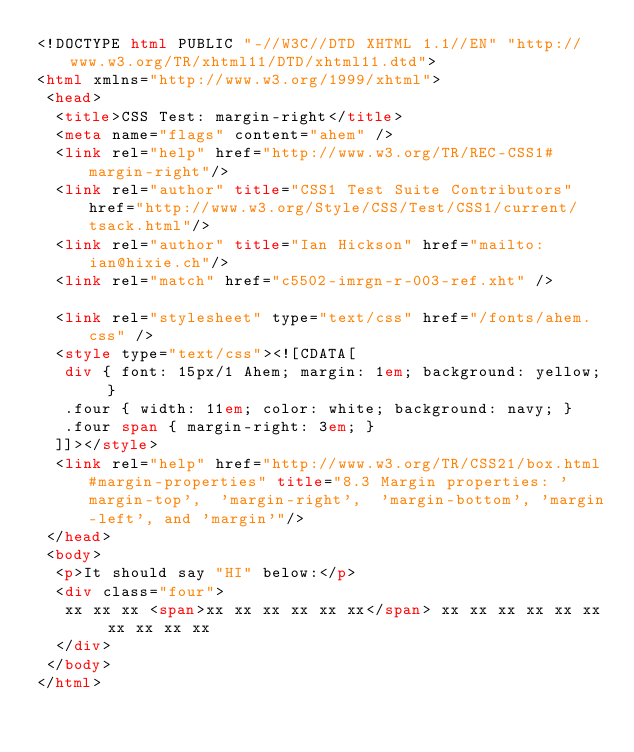Convert code to text. <code><loc_0><loc_0><loc_500><loc_500><_HTML_><!DOCTYPE html PUBLIC "-//W3C//DTD XHTML 1.1//EN" "http://www.w3.org/TR/xhtml11/DTD/xhtml11.dtd">
<html xmlns="http://www.w3.org/1999/xhtml">
 <head>
  <title>CSS Test: margin-right</title>
  <meta name="flags" content="ahem" />
  <link rel="help" href="http://www.w3.org/TR/REC-CSS1#margin-right"/>
  <link rel="author" title="CSS1 Test Suite Contributors" href="http://www.w3.org/Style/CSS/Test/CSS1/current/tsack.html"/>
  <link rel="author" title="Ian Hickson" href="mailto:ian@hixie.ch"/>
  <link rel="match" href="c5502-imrgn-r-003-ref.xht" />

  <link rel="stylesheet" type="text/css" href="/fonts/ahem.css" />
  <style type="text/css"><![CDATA[
   div { font: 15px/1 Ahem; margin: 1em; background: yellow; }
   .four { width: 11em; color: white; background: navy; }
   .four span { margin-right: 3em; }
  ]]></style>
  <link rel="help" href="http://www.w3.org/TR/CSS21/box.html#margin-properties" title="8.3 Margin properties: 'margin-top',  'margin-right',  'margin-bottom', 'margin-left', and 'margin'"/>
 </head>
 <body>
  <p>It should say "HI" below:</p>
  <div class="four">
   xx xx xx <span>xx xx xx xx xx xx</span> xx xx xx xx xx xx xx xx xx xx
  </div>
 </body>
</html>
</code> 